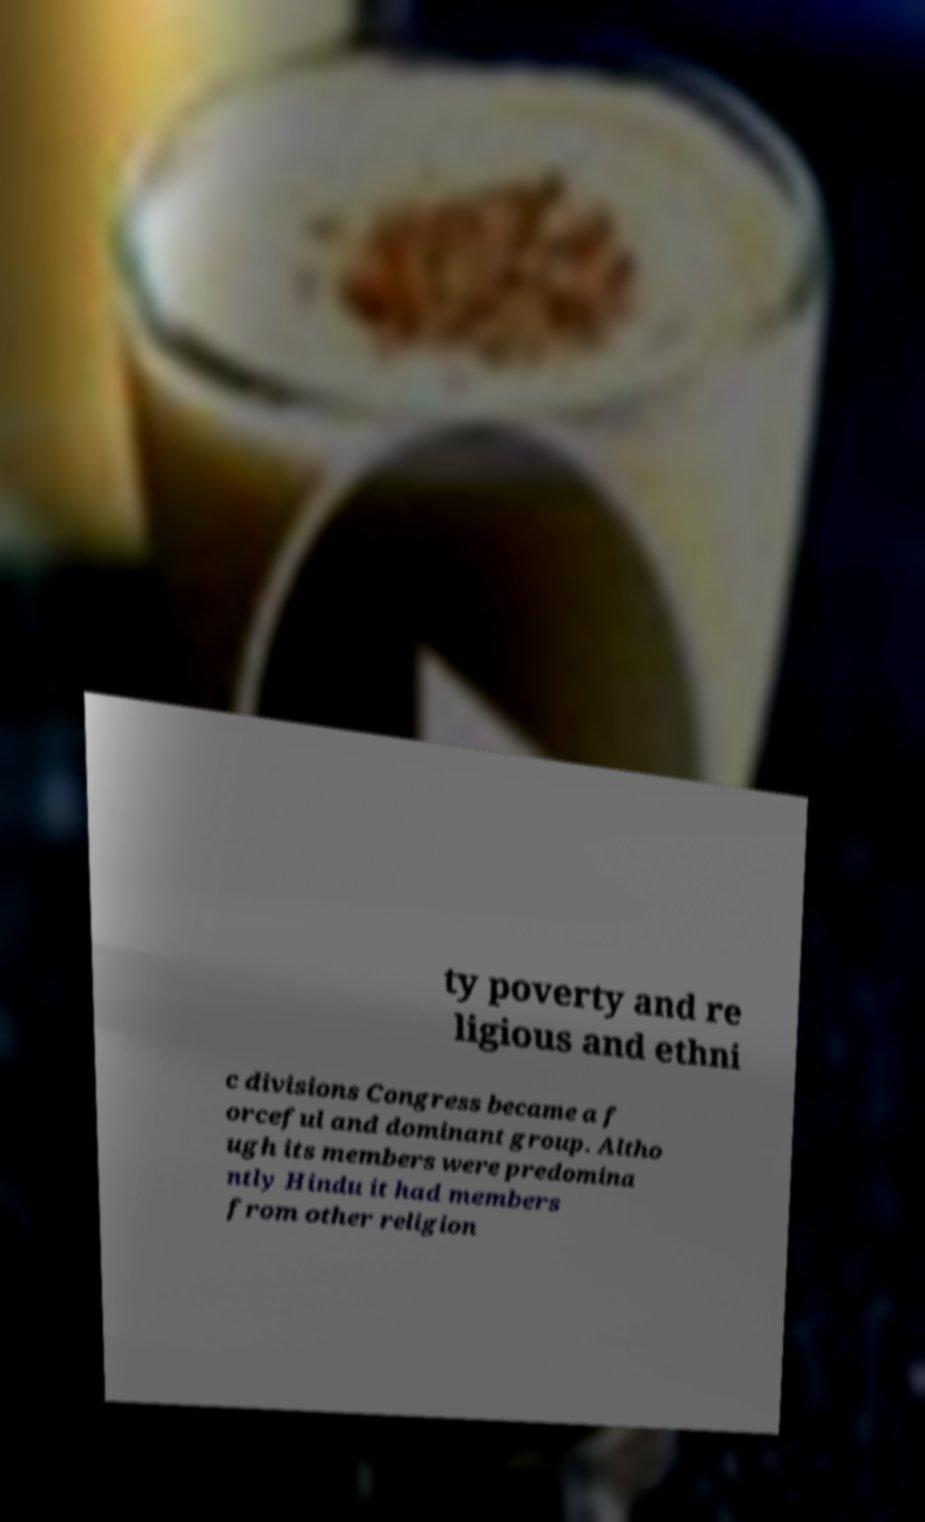What messages or text are displayed in this image? I need them in a readable, typed format. ty poverty and re ligious and ethni c divisions Congress became a f orceful and dominant group. Altho ugh its members were predomina ntly Hindu it had members from other religion 